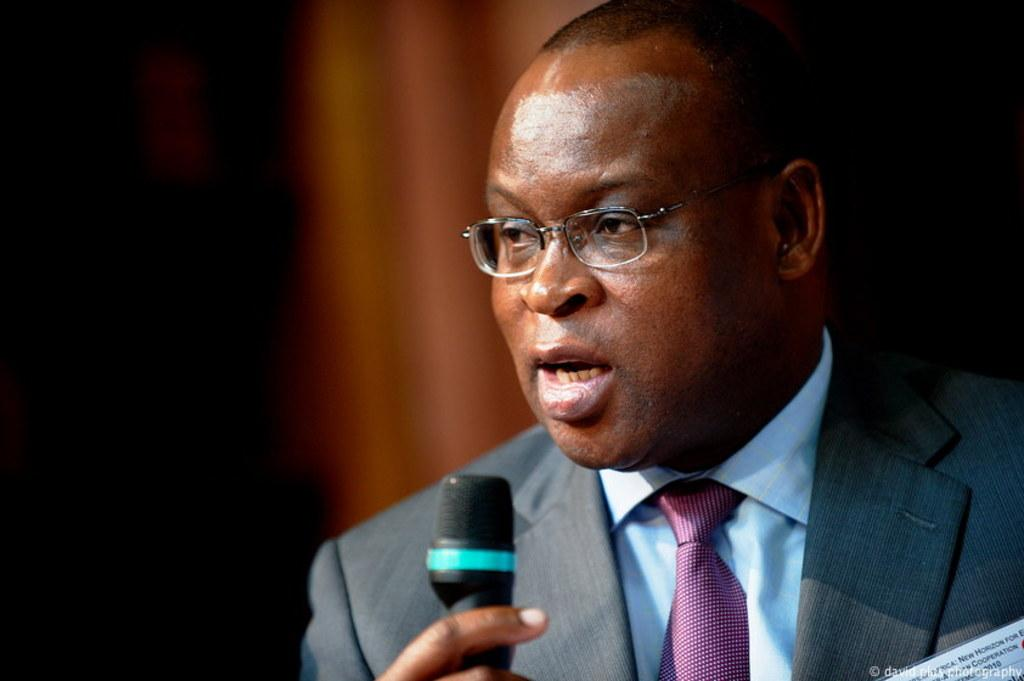Who is the main subject in the image? There is a person in the image. What is the person doing in the image? The person is standing and speaking. What is the person wearing in the image? The person is wearing a suit. What object is the person holding in the image? The person is holding a microphone in their hand. What type of art can be seen in the background of the image? There is no art visible in the background of the image. 